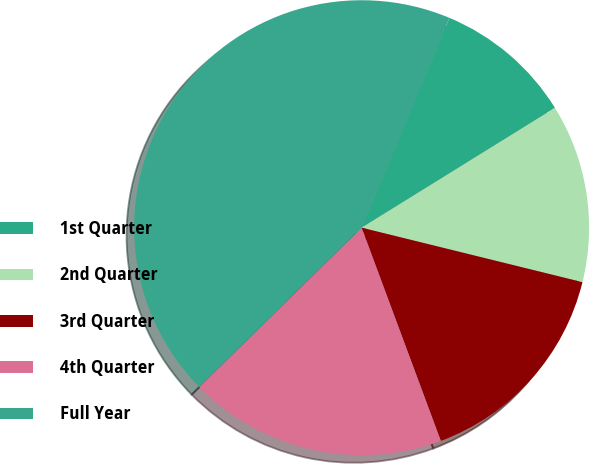Convert chart to OTSL. <chart><loc_0><loc_0><loc_500><loc_500><pie_chart><fcel>1st Quarter<fcel>2nd Quarter<fcel>3rd Quarter<fcel>4th Quarter<fcel>Full Year<nl><fcel>9.86%<fcel>12.68%<fcel>15.49%<fcel>18.31%<fcel>43.66%<nl></chart> 